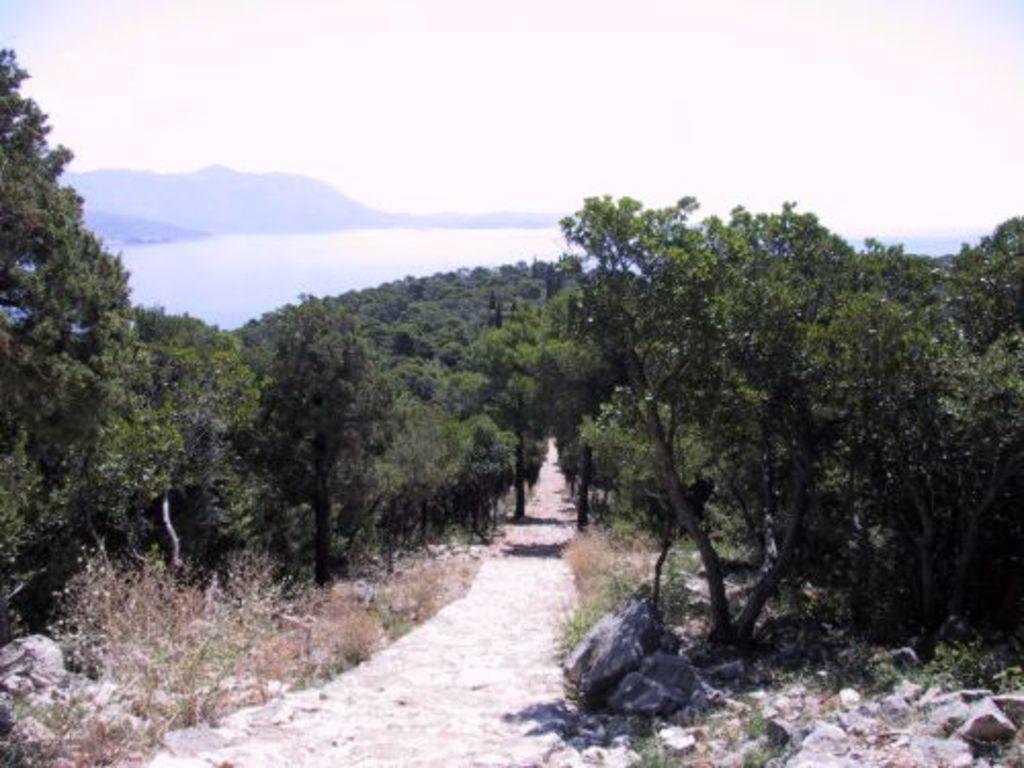How would you summarize this image in a sentence or two? In this image, we can see a path in between trees. There is a river and hill in the middle of the image. There is a sky at the top of the image. 